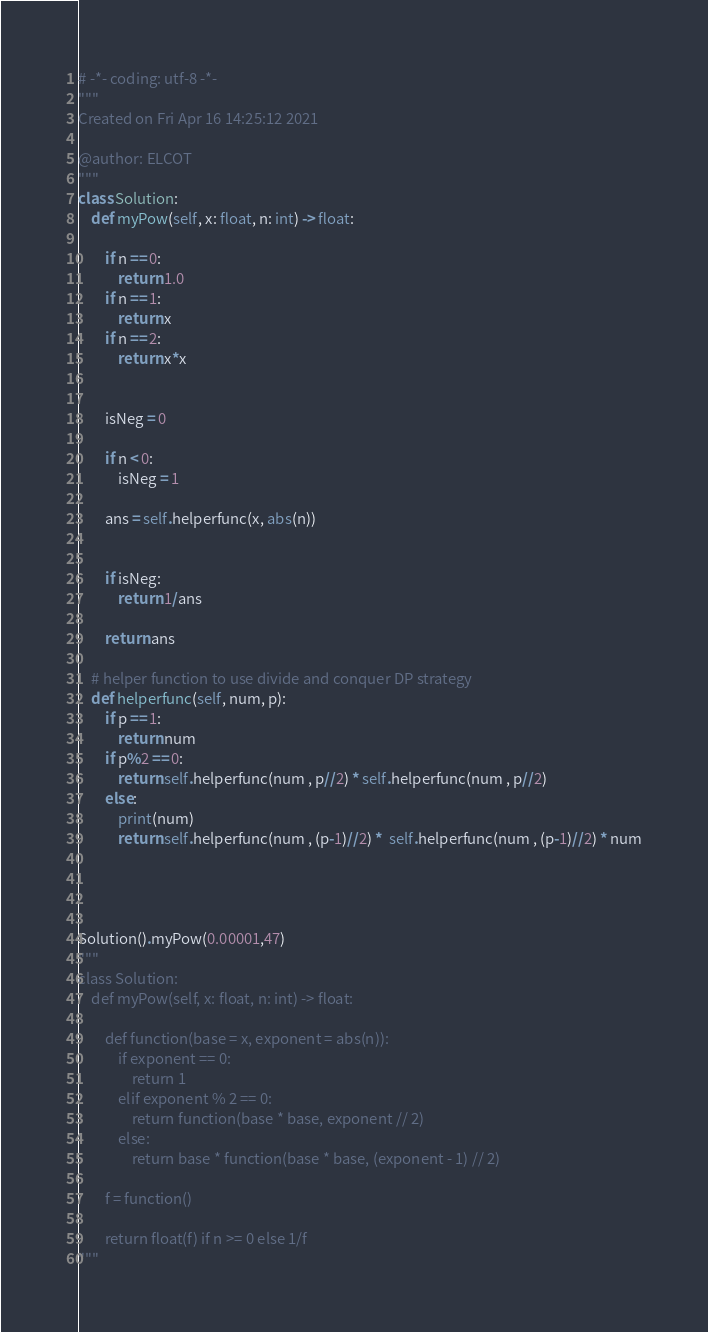Convert code to text. <code><loc_0><loc_0><loc_500><loc_500><_Python_># -*- coding: utf-8 -*-
"""
Created on Fri Apr 16 14:25:12 2021

@author: ELCOT
"""
class Solution:
    def myPow(self, x: float, n: int) -> float:
        
        if n == 0:
            return 1.0
        if n == 1:
            return x
        if n == 2:
            return x*x
        
        
        isNeg = 0
        
        if n < 0:
            isNeg = 1       
        
        ans = self.helperfunc(x, abs(n))
        
        
        if isNeg:
            return 1/ans
        
        return ans
    
    # helper function to use divide and conquer DP strategy
    def helperfunc(self, num, p):
        if p == 1:
            return num 
        if p%2 == 0:
            return self.helperfunc(num , p//2) * self.helperfunc(num , p//2)
        else:
            print(num)
            return self.helperfunc(num , (p-1)//2) *  self.helperfunc(num , (p-1)//2) * num
        
        
        
        
Solution().myPow(0.00001,47)
"""
class Solution:
    def myPow(self, x: float, n: int) -> float:

        def function(base = x, exponent = abs(n)):
            if exponent == 0:
                return 1
            elif exponent % 2 == 0:
                return function(base * base, exponent // 2)
            else:
                return base * function(base * base, (exponent - 1) // 2)

        f = function()
        
        return float(f) if n >= 0 else 1/f
"""</code> 